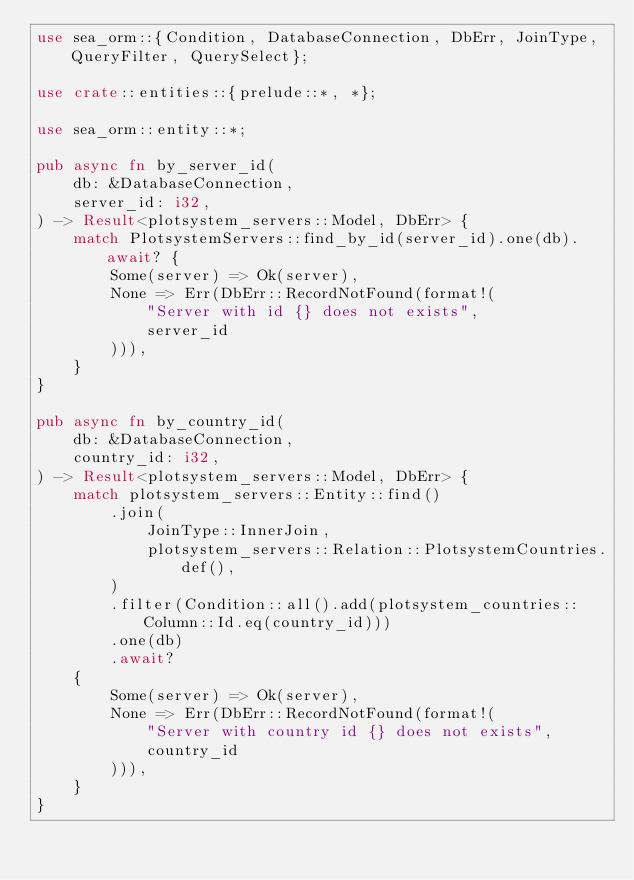Convert code to text. <code><loc_0><loc_0><loc_500><loc_500><_Rust_>use sea_orm::{Condition, DatabaseConnection, DbErr, JoinType, QueryFilter, QuerySelect};

use crate::entities::{prelude::*, *};

use sea_orm::entity::*;

pub async fn by_server_id(
    db: &DatabaseConnection,
    server_id: i32,
) -> Result<plotsystem_servers::Model, DbErr> {
    match PlotsystemServers::find_by_id(server_id).one(db).await? {
        Some(server) => Ok(server),
        None => Err(DbErr::RecordNotFound(format!(
            "Server with id {} does not exists",
            server_id
        ))),
    }
}

pub async fn by_country_id(
    db: &DatabaseConnection,
    country_id: i32,
) -> Result<plotsystem_servers::Model, DbErr> {
    match plotsystem_servers::Entity::find()
        .join(
            JoinType::InnerJoin,
            plotsystem_servers::Relation::PlotsystemCountries.def(),
        )
        .filter(Condition::all().add(plotsystem_countries::Column::Id.eq(country_id)))
        .one(db)
        .await?
    {
        Some(server) => Ok(server),
        None => Err(DbErr::RecordNotFound(format!(
            "Server with country id {} does not exists",
            country_id
        ))),
    }
}
</code> 